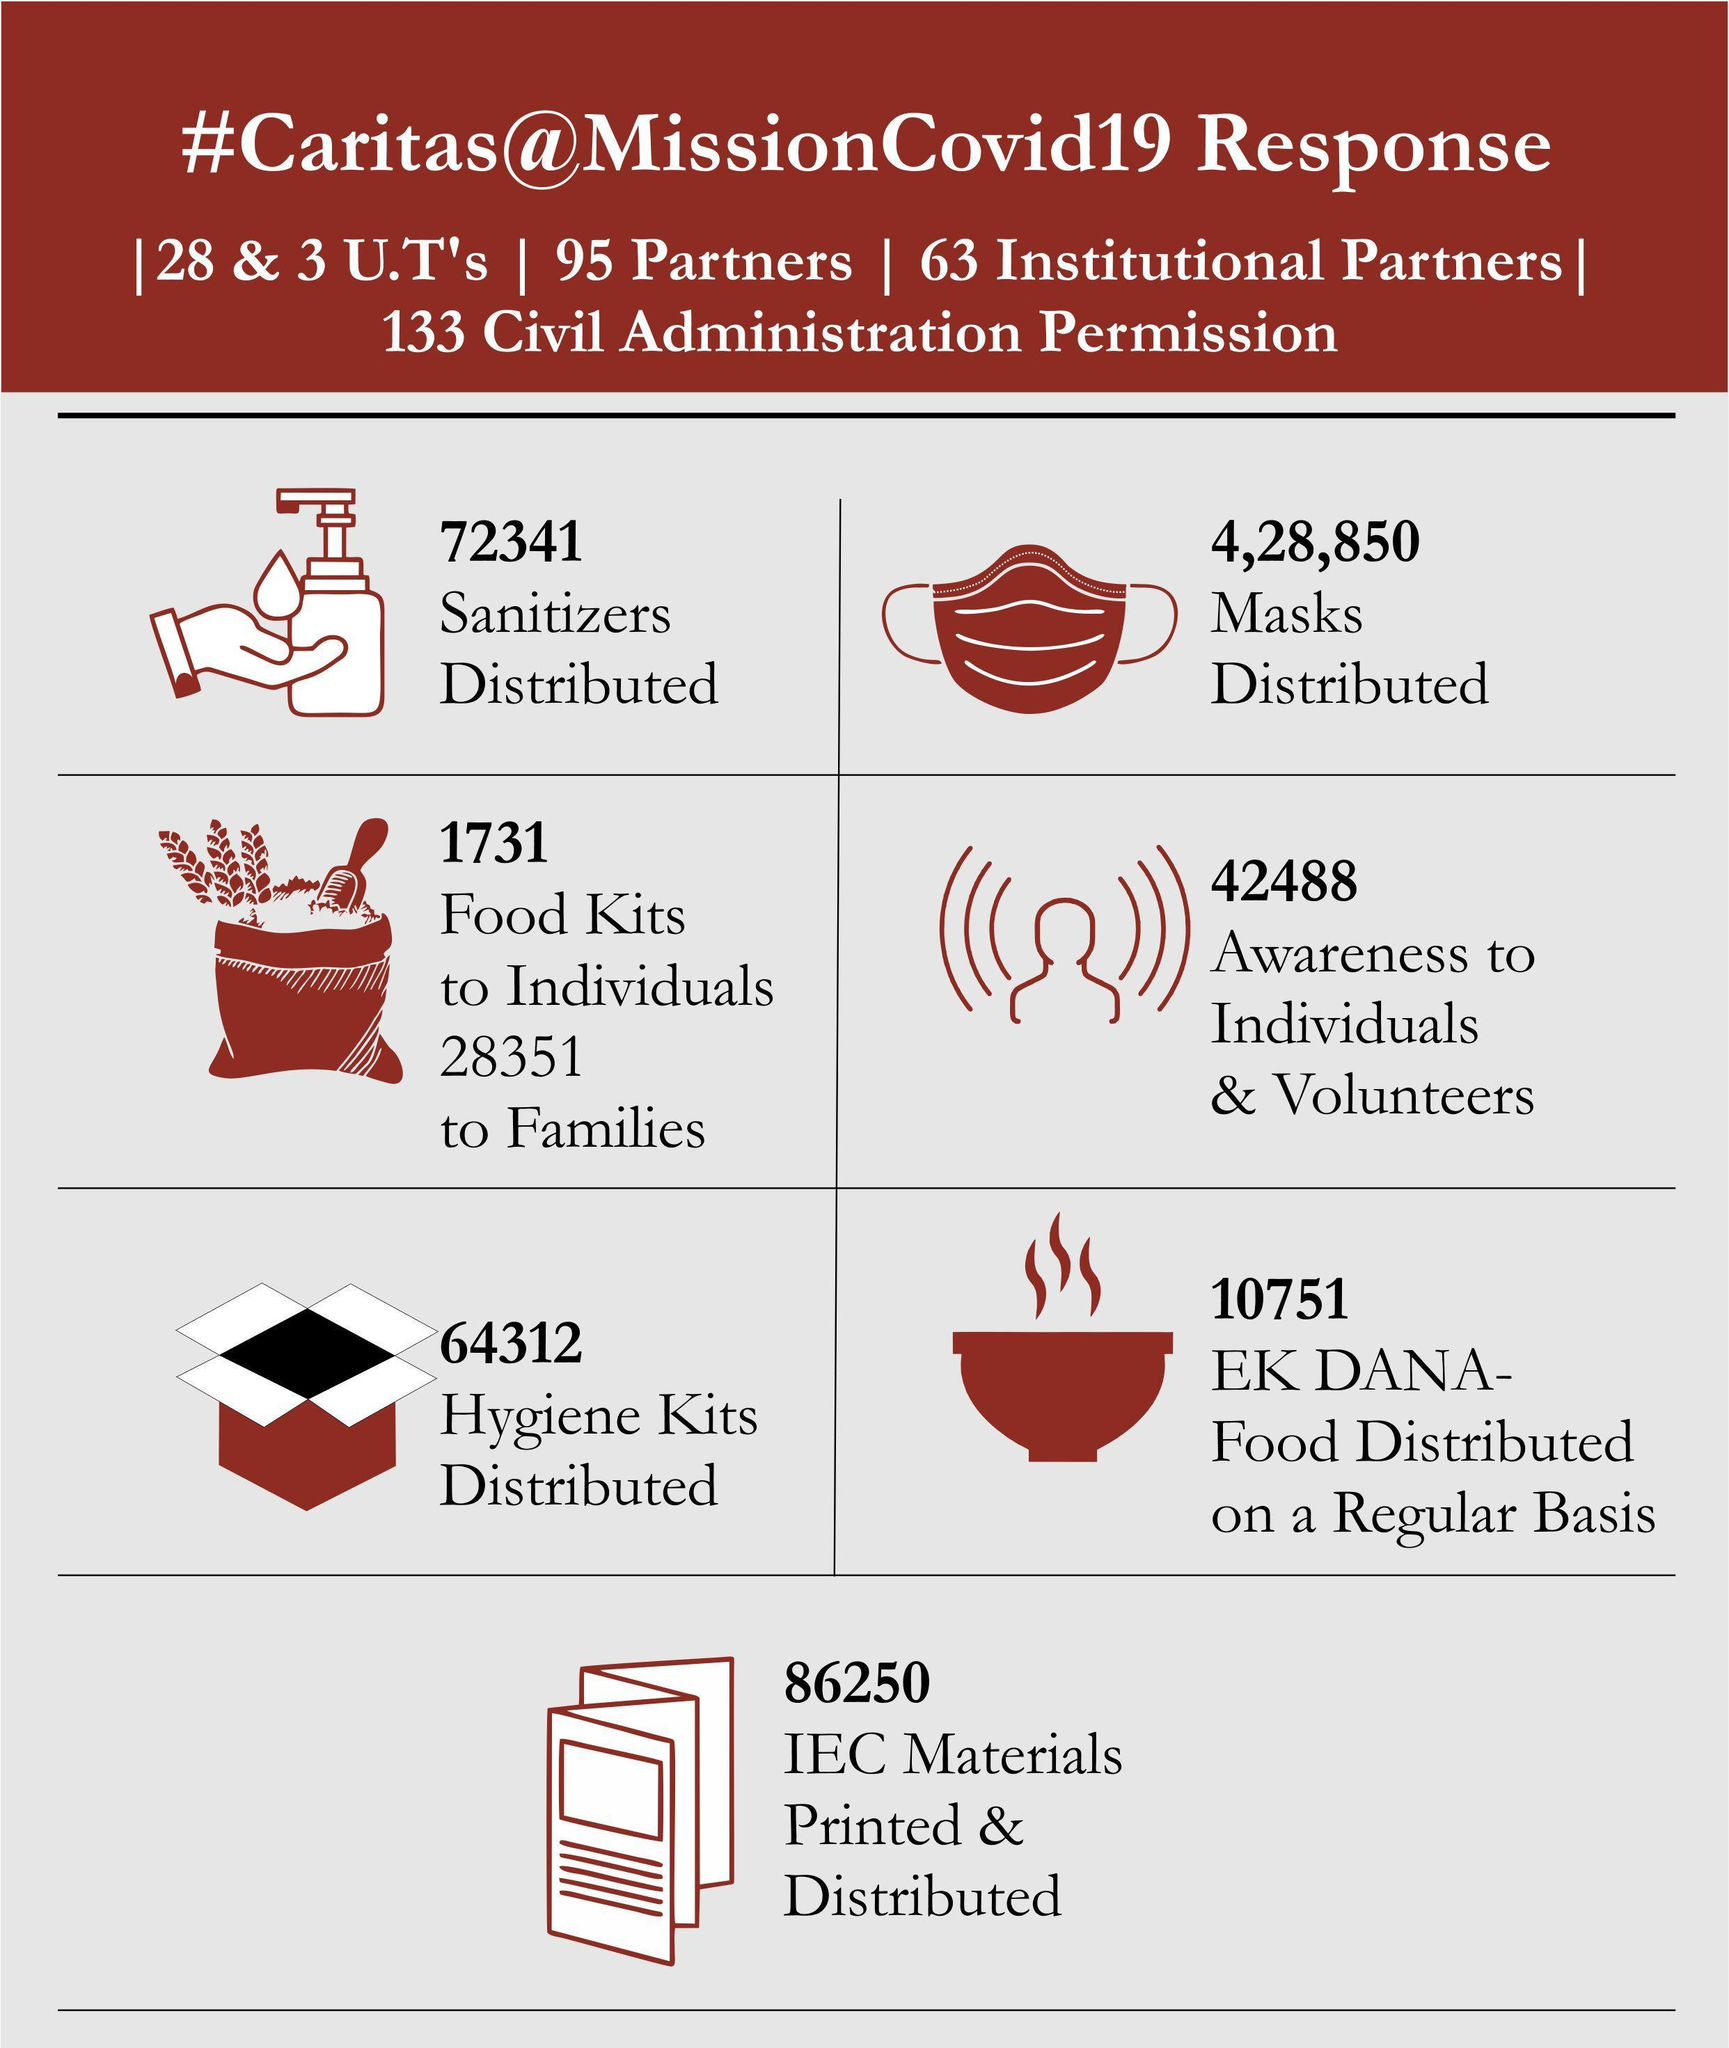How many food kits were distributed to both individuals and families?
Answer the question with a short phrase. 30,082 How many sanitizers and masks were distributed? 5,01,191 